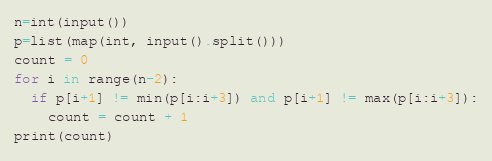<code> <loc_0><loc_0><loc_500><loc_500><_Python_>n=int(input())
p=list(map(int, input().split()))
count = 0
for i in range(n-2):
  if p[i+1] != min(p[i:i+3]) and p[i+1] != max(p[i:i+3]):
    count = count + 1
print(count)</code> 